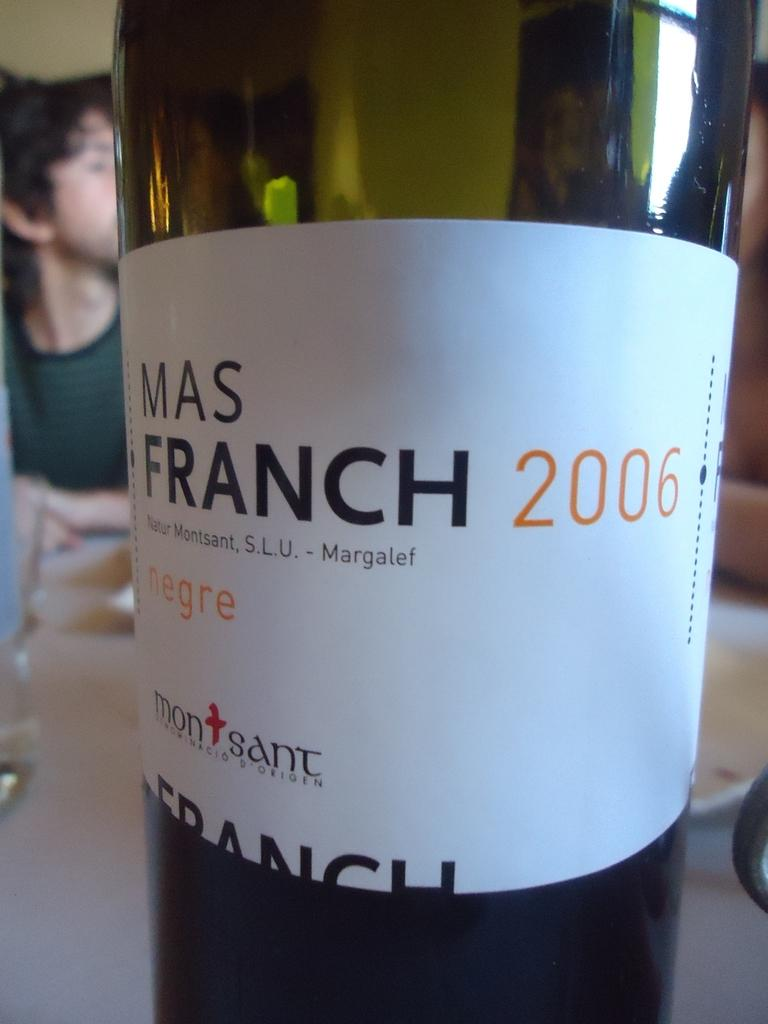<image>
Summarize the visual content of the image. A bottle of Mas Franch 2006 on the table. 